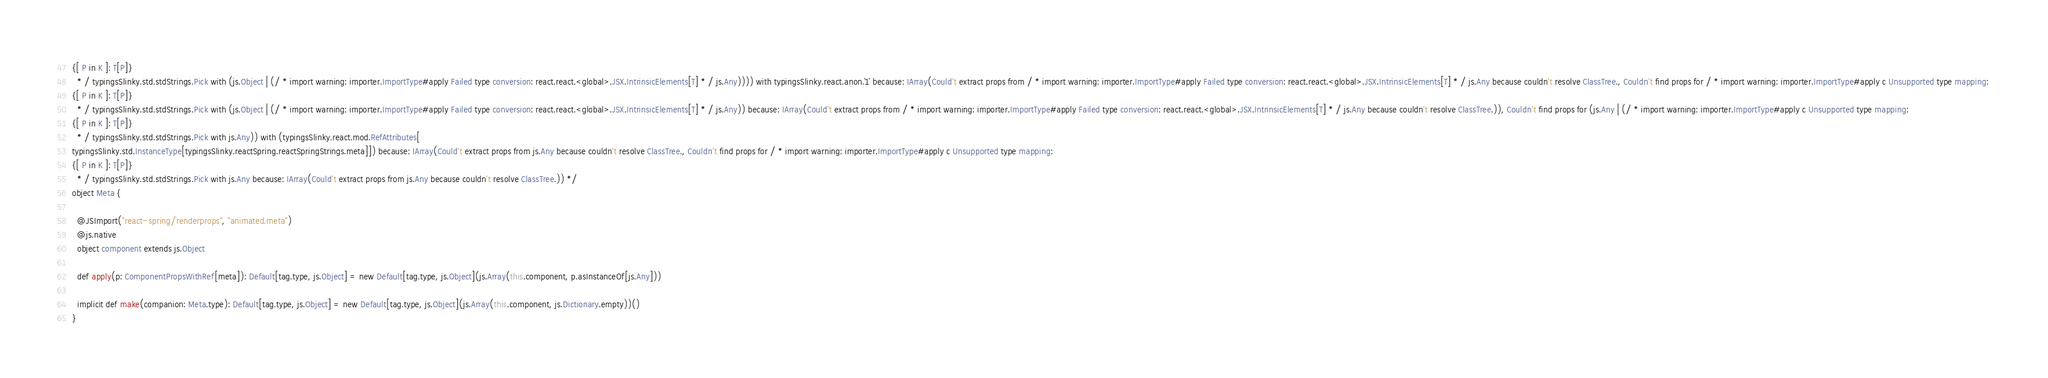<code> <loc_0><loc_0><loc_500><loc_500><_Scala_>{[ P in K ]: T[P]}
  * / typingsSlinky.std.stdStrings.Pick with (js.Object | (/ * import warning: importer.ImportType#apply Failed type conversion: react.react.<global>.JSX.IntrinsicElements[T] * / js.Any)))) with typingsSlinky.react.anon.`1` because: IArray(Could't extract props from / * import warning: importer.ImportType#apply Failed type conversion: react.react.<global>.JSX.IntrinsicElements[T] * / js.Any because couldn't resolve ClassTree., Couldn't find props for / * import warning: importer.ImportType#apply c Unsupported type mapping: 
{[ P in K ]: T[P]}
  * / typingsSlinky.std.stdStrings.Pick with (js.Object | (/ * import warning: importer.ImportType#apply Failed type conversion: react.react.<global>.JSX.IntrinsicElements[T] * / js.Any)) because: IArray(Could't extract props from / * import warning: importer.ImportType#apply Failed type conversion: react.react.<global>.JSX.IntrinsicElements[T] * / js.Any because couldn't resolve ClassTree.)), Couldn't find props for (js.Any | (/ * import warning: importer.ImportType#apply c Unsupported type mapping: 
{[ P in K ]: T[P]}
  * / typingsSlinky.std.stdStrings.Pick with js.Any)) with (typingsSlinky.react.mod.RefAttributes[
typingsSlinky.std.InstanceType[typingsSlinky.reactSpring.reactSpringStrings.meta]]) because: IArray(Could't extract props from js.Any because couldn't resolve ClassTree., Couldn't find props for / * import warning: importer.ImportType#apply c Unsupported type mapping: 
{[ P in K ]: T[P]}
  * / typingsSlinky.std.stdStrings.Pick with js.Any because: IArray(Could't extract props from js.Any because couldn't resolve ClassTree.)) */
object Meta {
  
  @JSImport("react-spring/renderprops", "animated.meta")
  @js.native
  object component extends js.Object
  
  def apply(p: ComponentPropsWithRef[meta]): Default[tag.type, js.Object] = new Default[tag.type, js.Object](js.Array(this.component, p.asInstanceOf[js.Any]))
  
  implicit def make(companion: Meta.type): Default[tag.type, js.Object] = new Default[tag.type, js.Object](js.Array(this.component, js.Dictionary.empty))()
}
</code> 